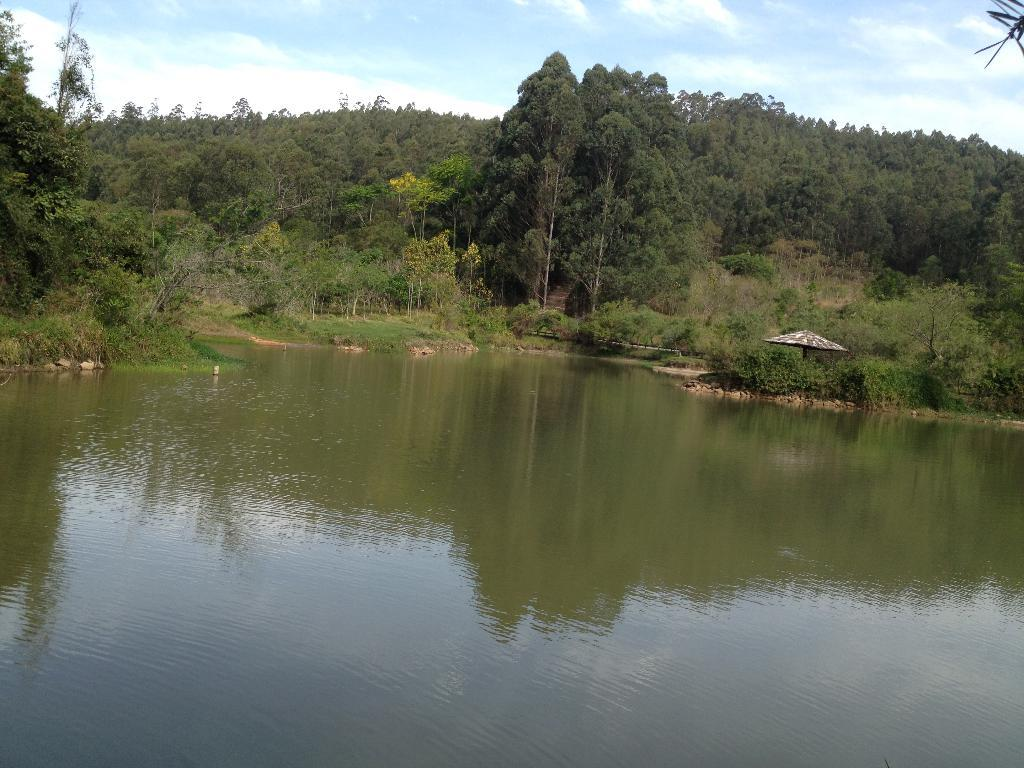What type of vegetation can be seen in the image? There is a group of trees in the image. What type of structure is present in the image? There is a shed in the image. What is visible in the foreground of the image? There is water visible in the foreground of the image. What is visible in the background of the image? The sky is visible in the background of the image. How would you describe the sky in the image? The sky appears to be cloudy in the image. Can you see a donkey grazing near the shed in the image? There is no donkey present in the image. How many cents are visible on the ground near the water in the image? There are no cents visible on the ground in the image. 